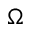<formula> <loc_0><loc_0><loc_500><loc_500>\Omega</formula> 